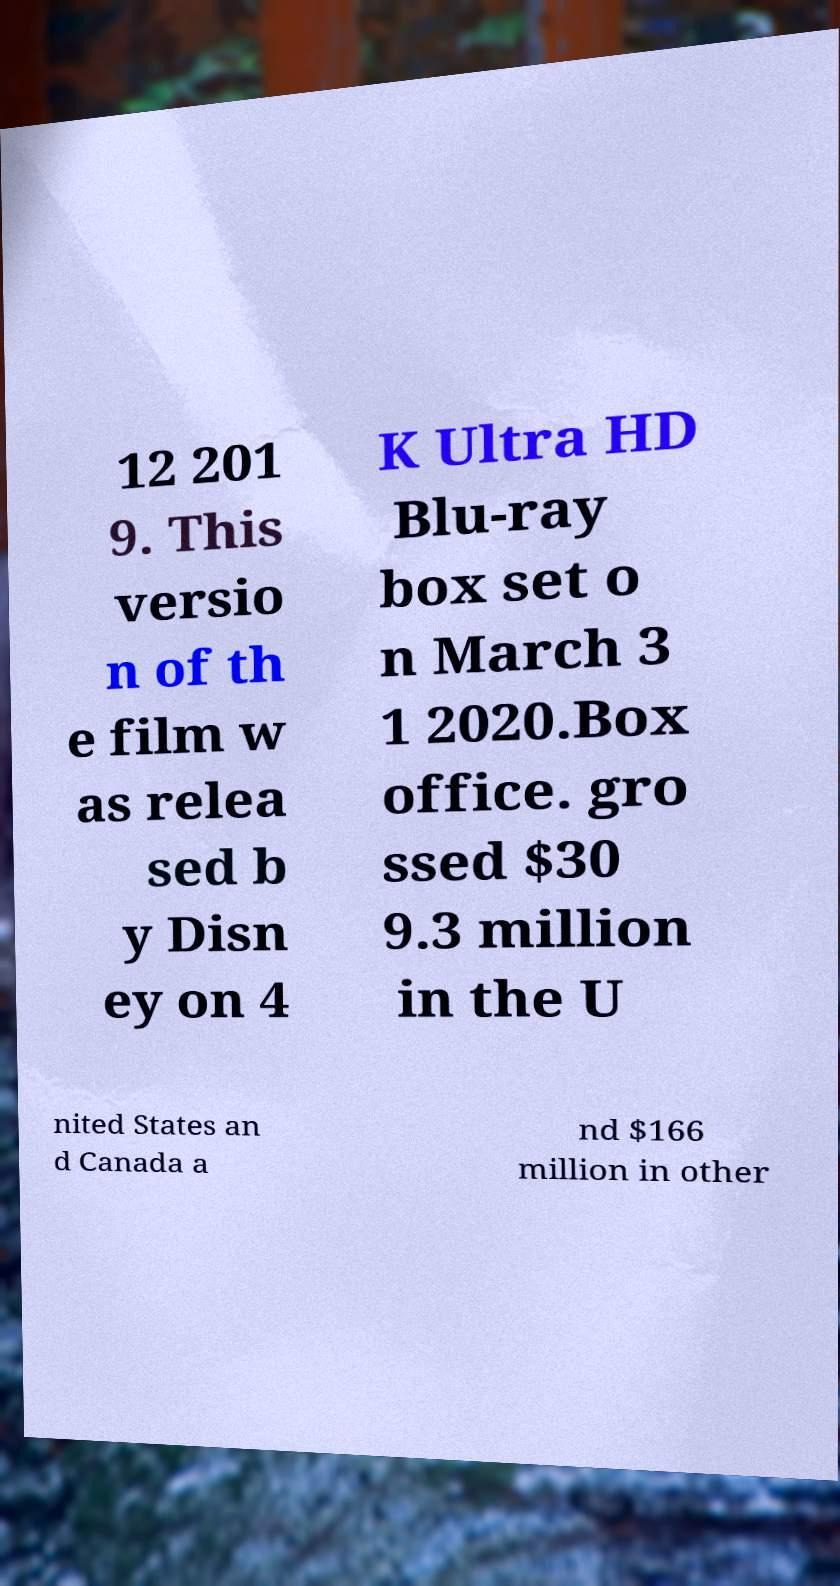There's text embedded in this image that I need extracted. Can you transcribe it verbatim? 12 201 9. This versio n of th e film w as relea sed b y Disn ey on 4 K Ultra HD Blu-ray box set o n March 3 1 2020.Box office. gro ssed $30 9.3 million in the U nited States an d Canada a nd $166 million in other 